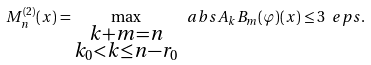Convert formula to latex. <formula><loc_0><loc_0><loc_500><loc_500>M ^ { ( 2 ) } _ { n } ( x ) = \max _ { \substack { k + m = n \\ k _ { 0 } < k \leq n - r _ { 0 } } } \ a b s { A _ { k } B _ { m } ( \varphi ) ( x ) } \leq 3 \ e p s .</formula> 